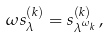<formula> <loc_0><loc_0><loc_500><loc_500>\omega s _ { \lambda } ^ { ( k ) } = s _ { \lambda ^ { \omega _ { k } } } ^ { ( k ) } \, ,</formula> 